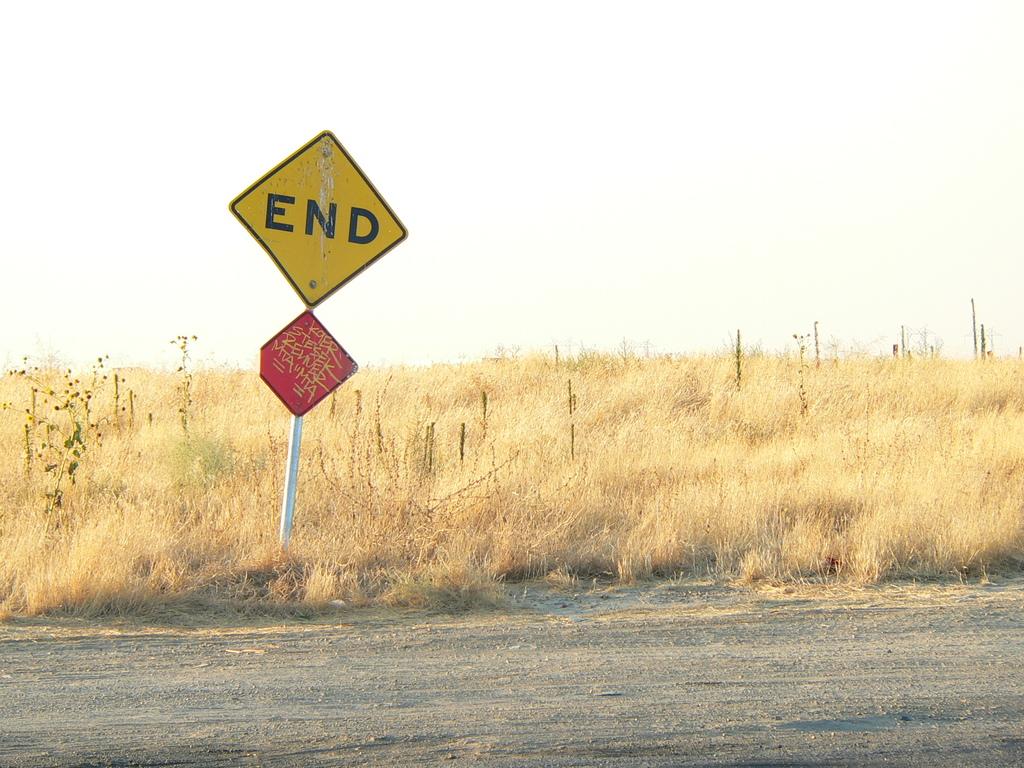What does the yellow sign say?
Provide a short and direct response. End. What are the three underlined letters on the red sign?
Keep it short and to the point. Mta. 